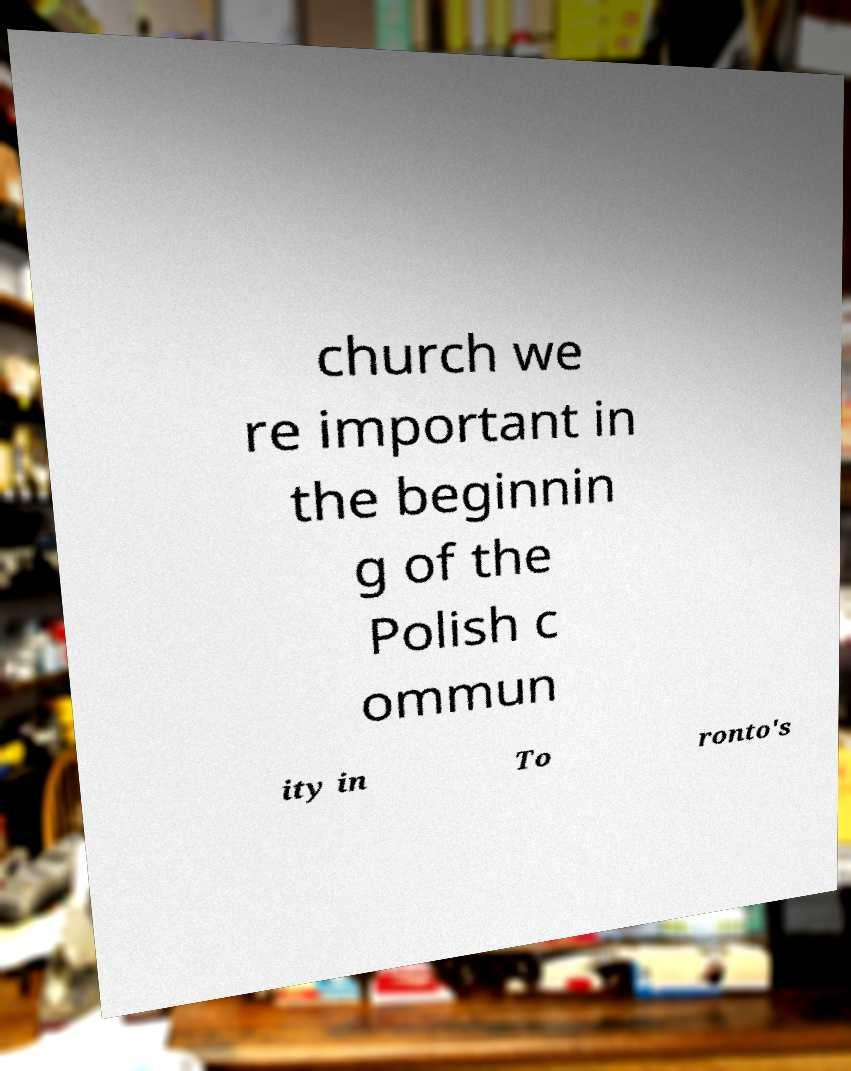Please identify and transcribe the text found in this image. church we re important in the beginnin g of the Polish c ommun ity in To ronto's 